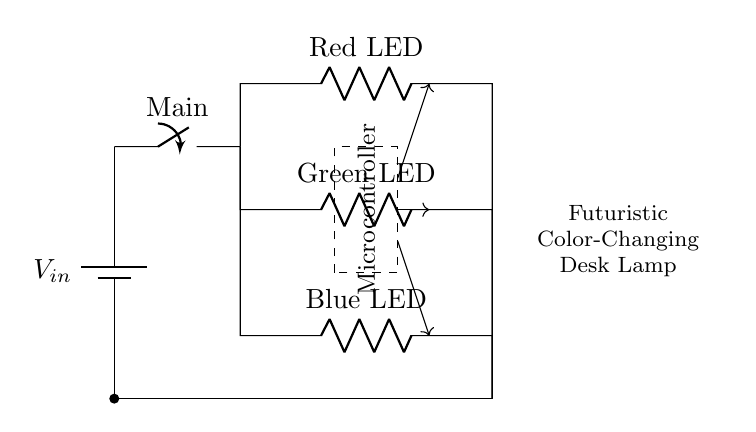What is the type of circuit represented? The circuit is a parallel circuit, where the components are connected parallel to each other, providing multiple pathways for current to flow.
Answer: Parallel How many LEDs are present in the circuit? There are three LEDs in the circuit: one red, one green, and one blue. Each LED is placed in its own parallel branch.
Answer: Three What is the role of the microcontroller in this circuit? The microcontroller manages the color-changing capabilities of the LEDs by controlling the voltage and current to each LED based on desired colors.
Answer: Control What is the purpose of the switch labeled 'Main'? The switch labeled 'Main' is used to turn the entire circuit on or off, allowing the user to control the power to the desk lamp.
Answer: Control power What happens if one LED fails in this circuit? If one LED fails, the other LEDs will still function, as they are connected in parallel, ensuring that the circuit can continue to operate.
Answer: Others still work What is the input voltage for this circuit? The input voltage labeled as V-in is provided from the battery, but the exact value is not specified in the diagram.
Answer: Unknown 